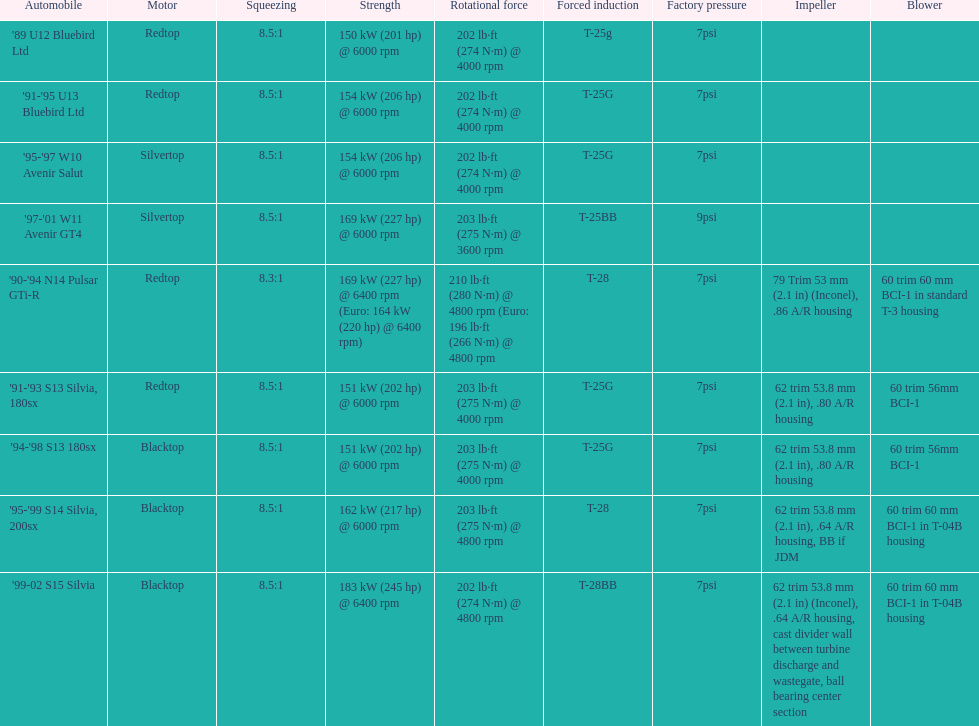Which car has a stock boost of over 7psi? '97-'01 W11 Avenir GT4. 